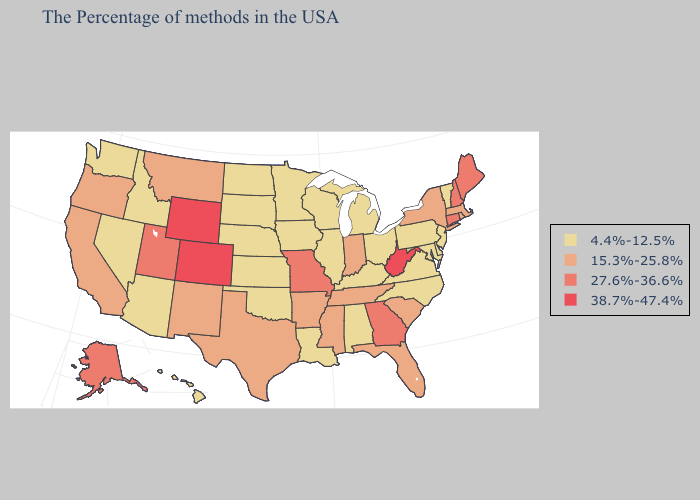Name the states that have a value in the range 4.4%-12.5%?
Short answer required. Vermont, New Jersey, Delaware, Maryland, Pennsylvania, Virginia, North Carolina, Ohio, Michigan, Kentucky, Alabama, Wisconsin, Illinois, Louisiana, Minnesota, Iowa, Kansas, Nebraska, Oklahoma, South Dakota, North Dakota, Arizona, Idaho, Nevada, Washington, Hawaii. Which states have the lowest value in the USA?
Quick response, please. Vermont, New Jersey, Delaware, Maryland, Pennsylvania, Virginia, North Carolina, Ohio, Michigan, Kentucky, Alabama, Wisconsin, Illinois, Louisiana, Minnesota, Iowa, Kansas, Nebraska, Oklahoma, South Dakota, North Dakota, Arizona, Idaho, Nevada, Washington, Hawaii. Among the states that border Wisconsin , which have the highest value?
Short answer required. Michigan, Illinois, Minnesota, Iowa. Among the states that border Virginia , does Kentucky have the highest value?
Write a very short answer. No. Does Oklahoma have the lowest value in the USA?
Quick response, please. Yes. Does Massachusetts have a higher value than Louisiana?
Keep it brief. Yes. What is the lowest value in the USA?
Short answer required. 4.4%-12.5%. Does Virginia have the highest value in the USA?
Be succinct. No. Does Indiana have the lowest value in the MidWest?
Keep it brief. No. What is the value of Hawaii?
Short answer required. 4.4%-12.5%. What is the lowest value in states that border North Carolina?
Answer briefly. 4.4%-12.5%. Name the states that have a value in the range 4.4%-12.5%?
Short answer required. Vermont, New Jersey, Delaware, Maryland, Pennsylvania, Virginia, North Carolina, Ohio, Michigan, Kentucky, Alabama, Wisconsin, Illinois, Louisiana, Minnesota, Iowa, Kansas, Nebraska, Oklahoma, South Dakota, North Dakota, Arizona, Idaho, Nevada, Washington, Hawaii. What is the value of South Dakota?
Be succinct. 4.4%-12.5%. What is the highest value in the West ?
Give a very brief answer. 38.7%-47.4%. What is the highest value in states that border New Mexico?
Concise answer only. 38.7%-47.4%. 